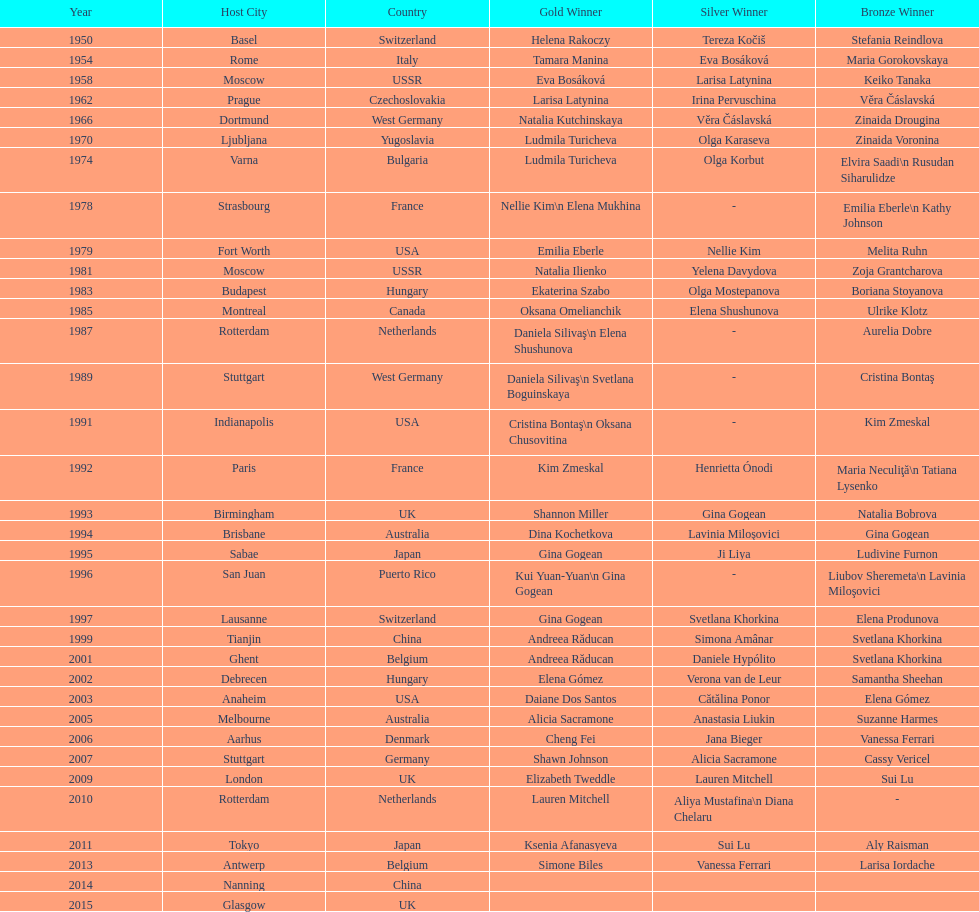As of 2013, what is the total number of floor exercise gold medals won by american women at the world championships? 5. 